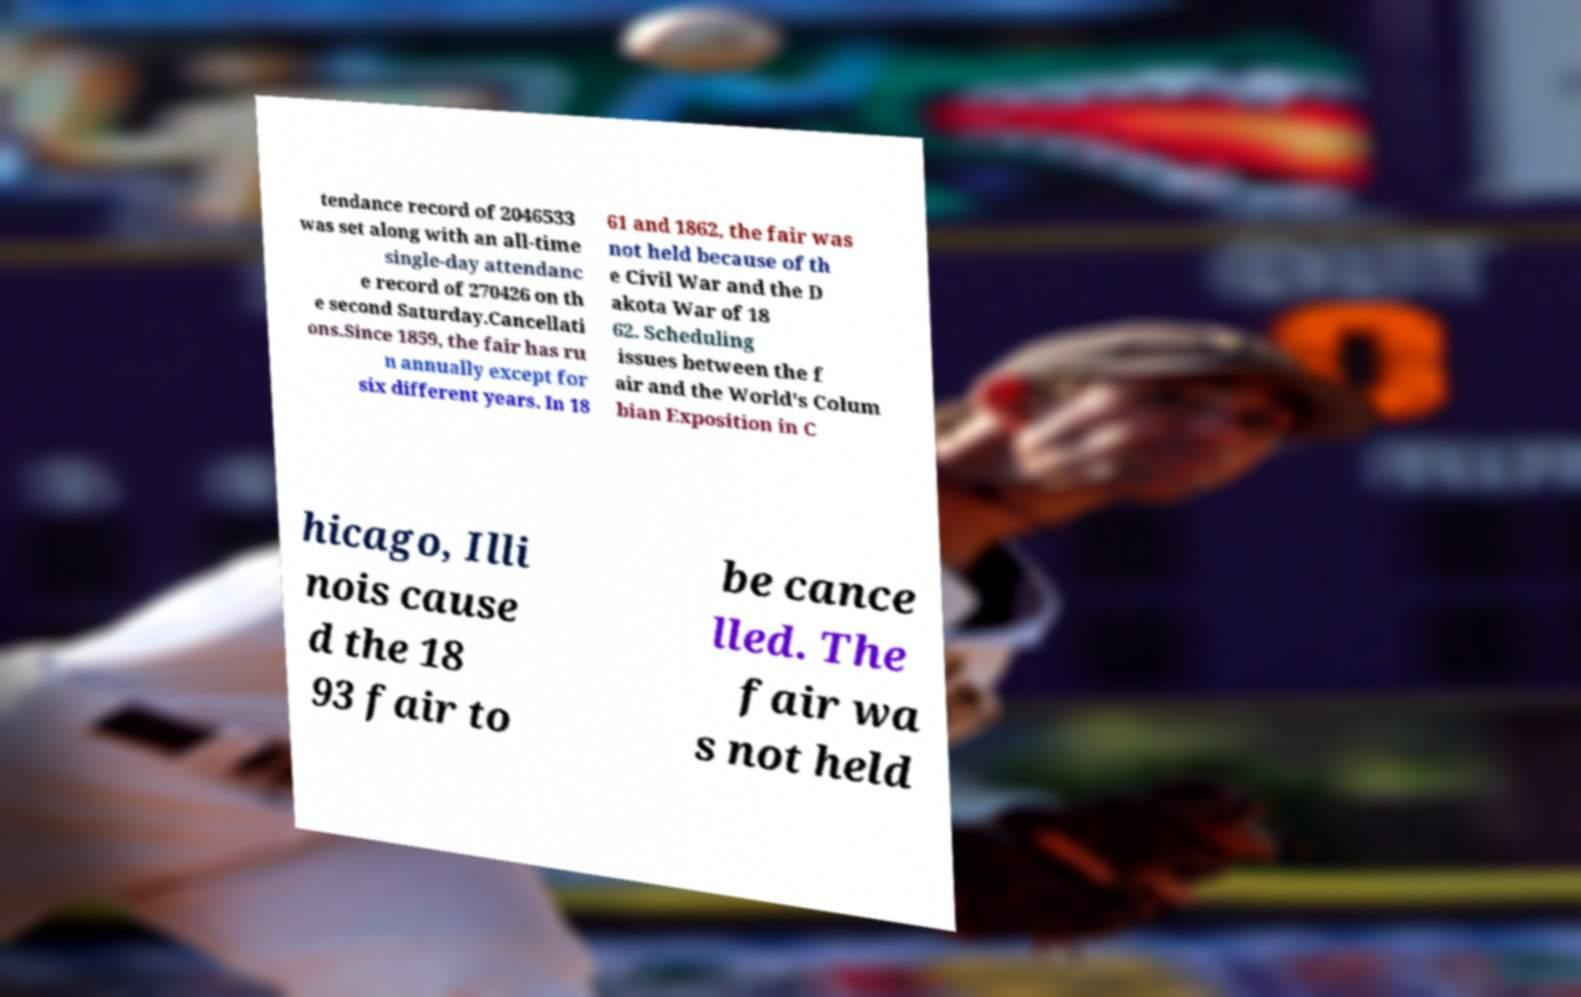Please identify and transcribe the text found in this image. tendance record of 2046533 was set along with an all-time single-day attendanc e record of 270426 on th e second Saturday.Cancellati ons.Since 1859, the fair has ru n annually except for six different years. In 18 61 and 1862, the fair was not held because of th e Civil War and the D akota War of 18 62. Scheduling issues between the f air and the World's Colum bian Exposition in C hicago, Illi nois cause d the 18 93 fair to be cance lled. The fair wa s not held 